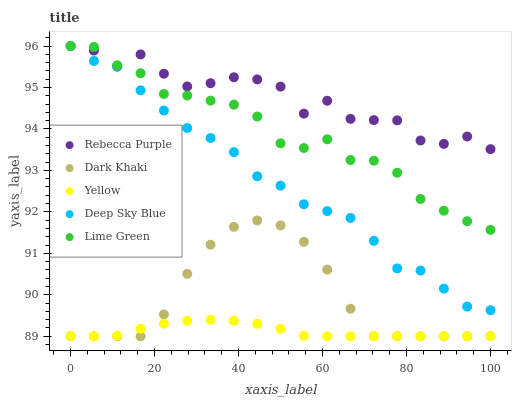Does Yellow have the minimum area under the curve?
Answer yes or no. Yes. Does Rebecca Purple have the maximum area under the curve?
Answer yes or no. Yes. Does Deep Sky Blue have the minimum area under the curve?
Answer yes or no. No. Does Deep Sky Blue have the maximum area under the curve?
Answer yes or no. No. Is Yellow the smoothest?
Answer yes or no. Yes. Is Rebecca Purple the roughest?
Answer yes or no. Yes. Is Deep Sky Blue the smoothest?
Answer yes or no. No. Is Deep Sky Blue the roughest?
Answer yes or no. No. Does Dark Khaki have the lowest value?
Answer yes or no. Yes. Does Deep Sky Blue have the lowest value?
Answer yes or no. No. Does Rebecca Purple have the highest value?
Answer yes or no. Yes. Does Yellow have the highest value?
Answer yes or no. No. Is Yellow less than Lime Green?
Answer yes or no. Yes. Is Deep Sky Blue greater than Dark Khaki?
Answer yes or no. Yes. Does Lime Green intersect Rebecca Purple?
Answer yes or no. Yes. Is Lime Green less than Rebecca Purple?
Answer yes or no. No. Is Lime Green greater than Rebecca Purple?
Answer yes or no. No. Does Yellow intersect Lime Green?
Answer yes or no. No. 